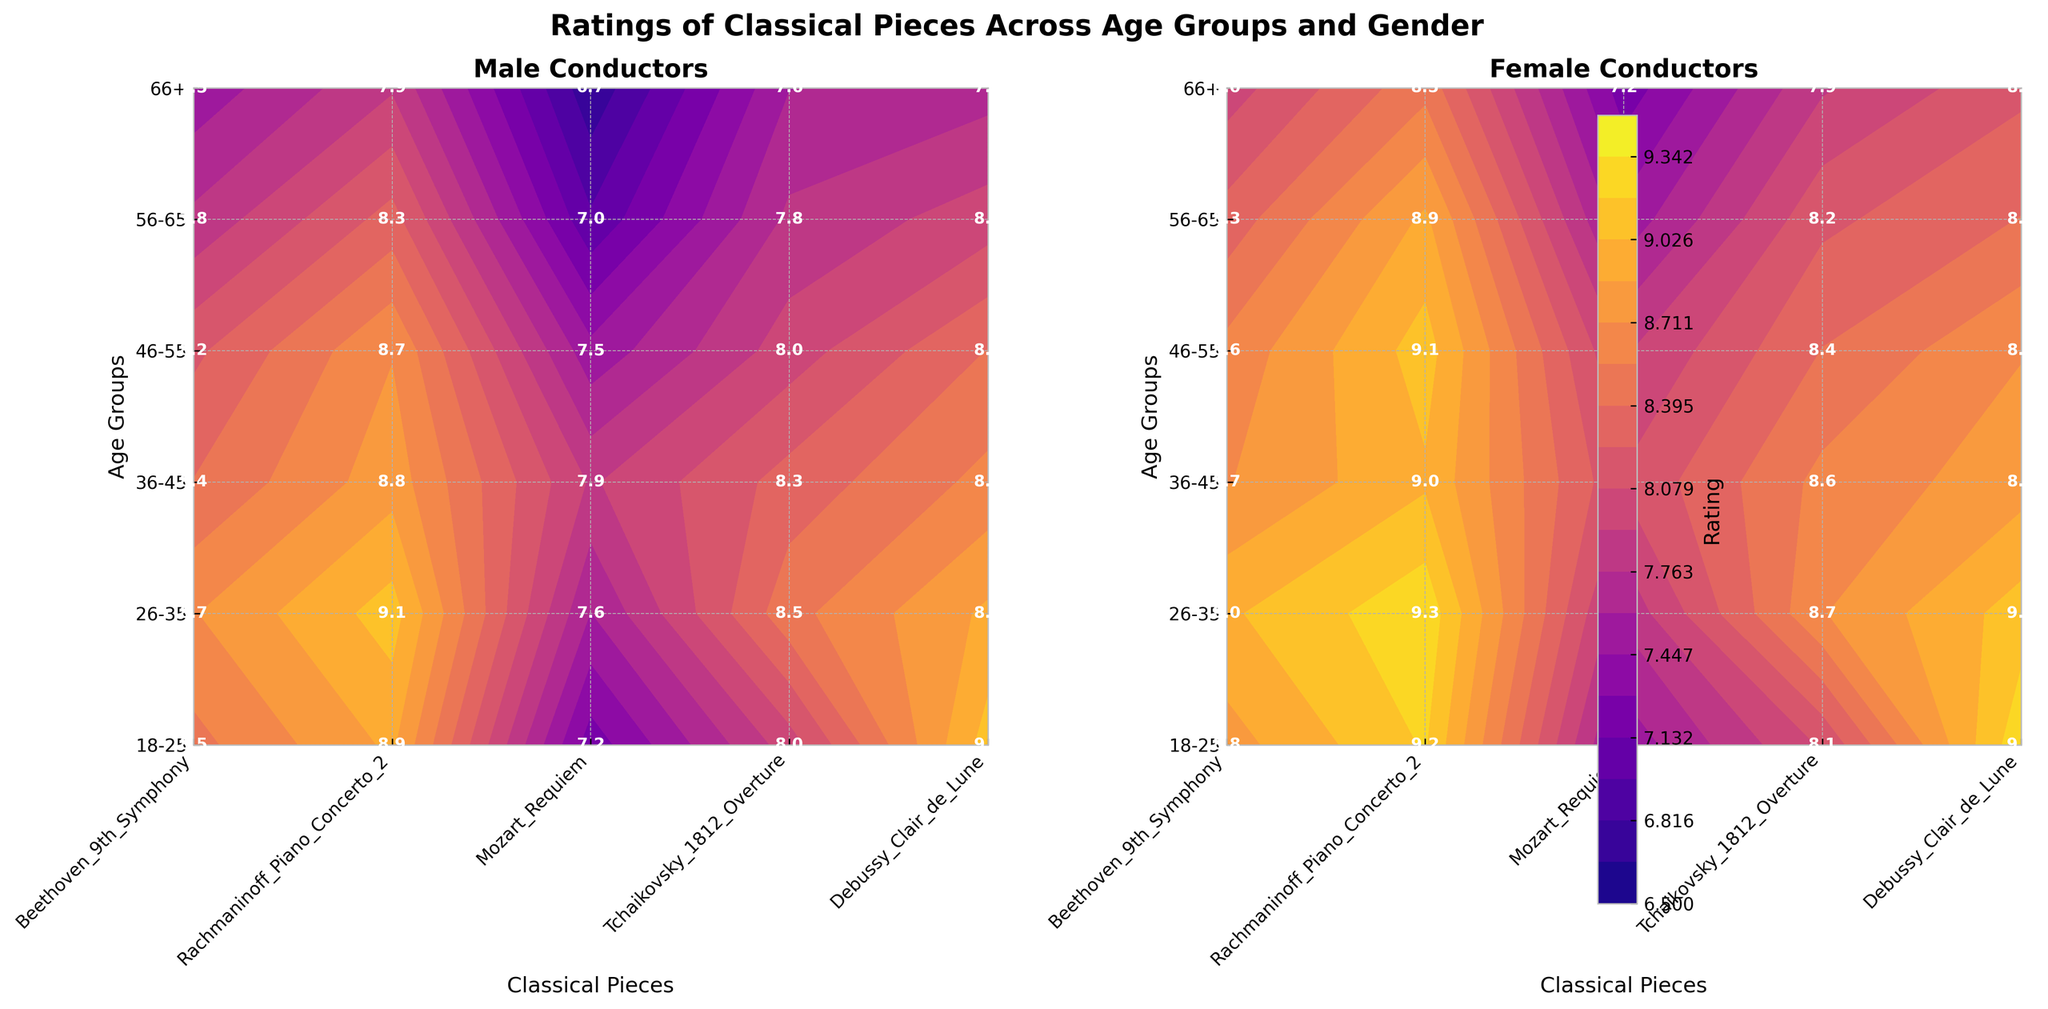Which gender group gave the highest rating to Beethoven's 9th Symphony in the 18-25 age group? The contours in the figure show that for Beethoven's 9th Symphony in the 18-25 age group, the rating by Female conductors is 8.8 compared to 8.5 by Male conductors.
Answer: Female What is the average rating for Debussy's Clair de Lune among 26-35 Male and Female conductors? For Debussy's Clair de Lune, the ratings are 8.9 from Male and 9.1 from Female conductors in the 26-35 age group. The average rating is (8.9 + 9.1) / 2 = 9.0.
Answer: 9.0 In which age group did Male conductors give the lowest rating to Tchaikovsky's 1812 Overture? By examining the contour labels for Tchaikovsky's 1812 Overture in the Male group, the lowest rating is 7.6 given by the 66+ age group.
Answer: 66+ Which classical piece received a generally higher rating from Female conductors across all age groups as compared to Male conductors? By comparing each piece across the figure, Debussy's Clair de Lune consistently received higher ratings from Female conductors than Male conductors in all age groups.
Answer: Debussy's Clair de Lune What is the range of ratings for Male conductors in the 56-65 age group? For the 56-65 Male age group, the ratings range from 7.0 (Mozart's Requiem) to 8.3 (Rachmaninoff's Piano Concerto 2). The range is 8.3 - 7.0 = 1.3.
Answer: 1.3 Compare the highest rating given by Female conductors in the 36-45 age group with the highest rating given by Male conductors in the same age group. In the 36-45 age group, Female conductors gave the highest rating of 9.0 to Rachmaninoff's Piano Concerto 2 and Male conductors gave the highest rating of 8.8 to the same piece.
Answer: 9.0 vs. 8.8 Which age group of Female conductors rated Mozart's Requiem the highest? The highest rating for Mozart's Requiem by Female conductors is 8.1, given by the 36-45 age group.
Answer: 36-45 What is the difference in the rating of Tchaikovsky's 1812 Overture between Male conductors in the 46-55 age group and Female conductors in the same age group? Tchaikovsky's 1812 Overture is rated 8.0 by Male conductors and 8.4 by Female conductors in the 46-55 age group. The difference is 8.4 - 8.0 = 0.4.
Answer: 0.4 Which classical piece shows the smallest rating difference between any gender group in the 66+ age group? For the 66+ age group, Beethoven's 9th Symphony has ratings of 7.5 (Male) and 8.0 (Female), with a difference of 0.5. The next smallest difference is for Debussy's Clair de Lune with a difference of 0.5. Therefore, both pieces tie for the smallest rating difference.
Answer: Beethoven's 9th Symphony and Debussy's Clair de Lune Which age group gave the overall highest rating across both Male and Female conductors? By examining the ratings, the Female conductors in the 26-35 age group gave the highest rating of 9.3 to both Rachmaninoff's Piano Concerto 2 and Beethoven's 9th Symphony.
Answer: 26-35 